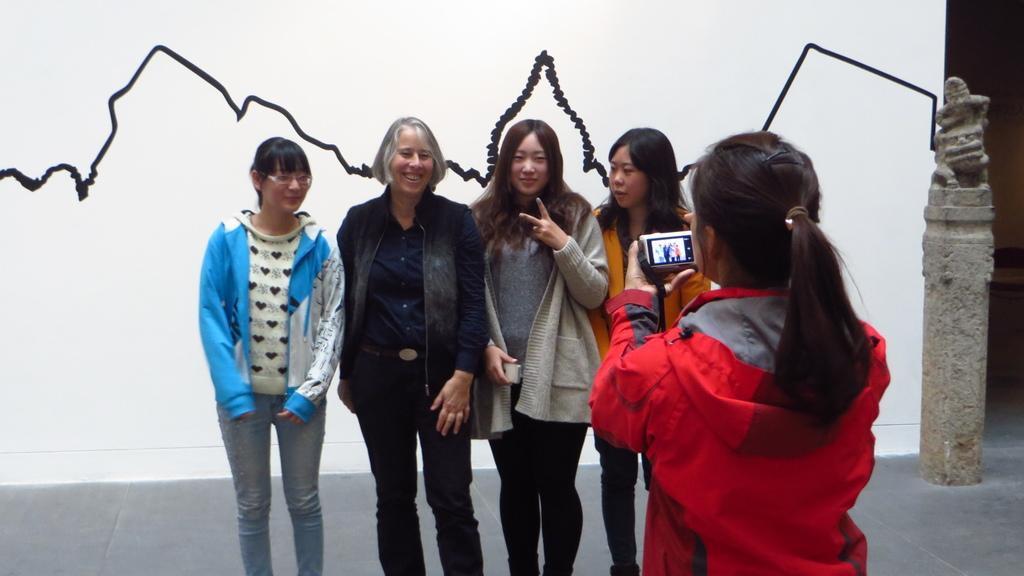How would you summarize this image in a sentence or two? There are people standing and she is holding a camera. In the background we can see black line on the wall and statue. 